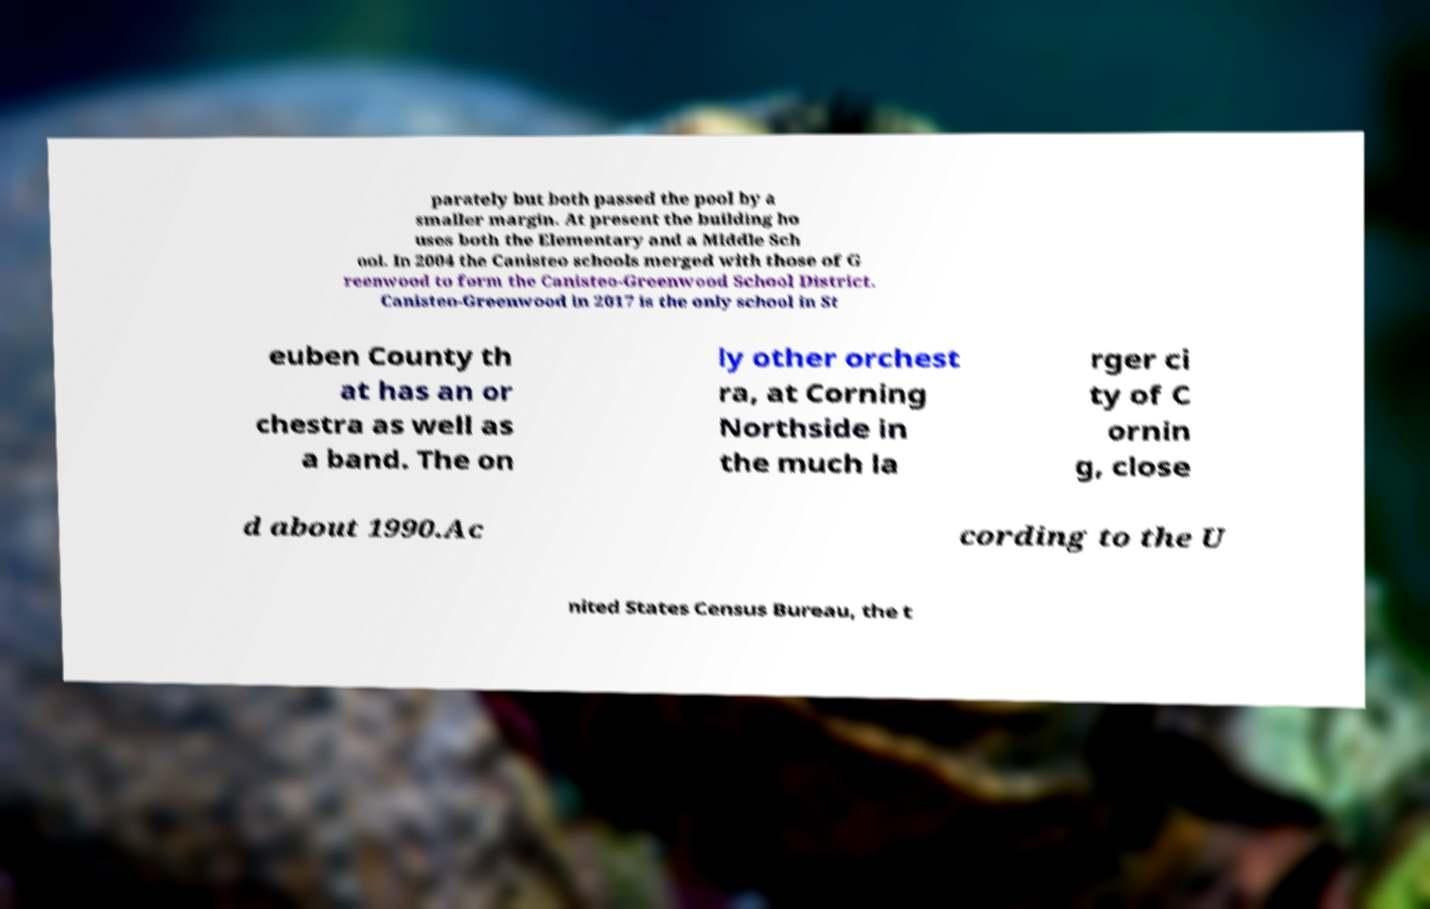Please identify and transcribe the text found in this image. parately but both passed the pool by a smaller margin. At present the building ho uses both the Elementary and a Middle Sch ool. In 2004 the Canisteo schools merged with those of G reenwood to form the Canisteo-Greenwood School District. Canisteo-Greenwood in 2017 is the only school in St euben County th at has an or chestra as well as a band. The on ly other orchest ra, at Corning Northside in the much la rger ci ty of C ornin g, close d about 1990.Ac cording to the U nited States Census Bureau, the t 